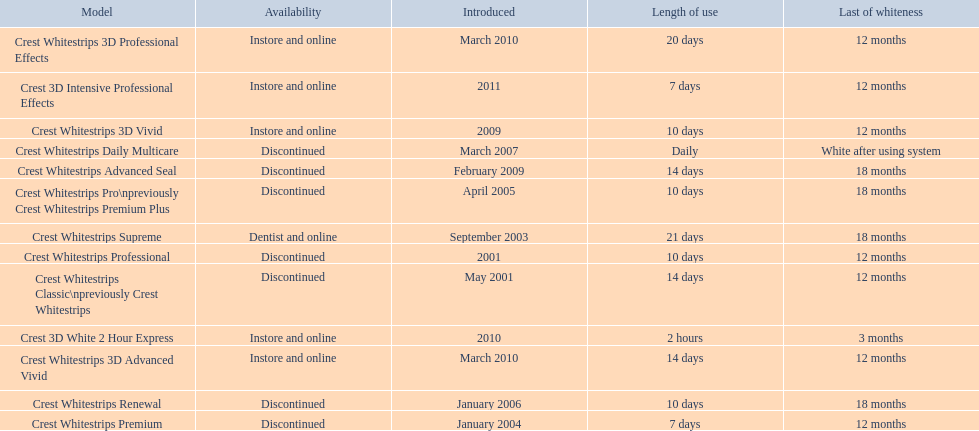Which model has the highest 'length of use' to 'last of whiteness' ratio? Crest Whitestrips Supreme. 